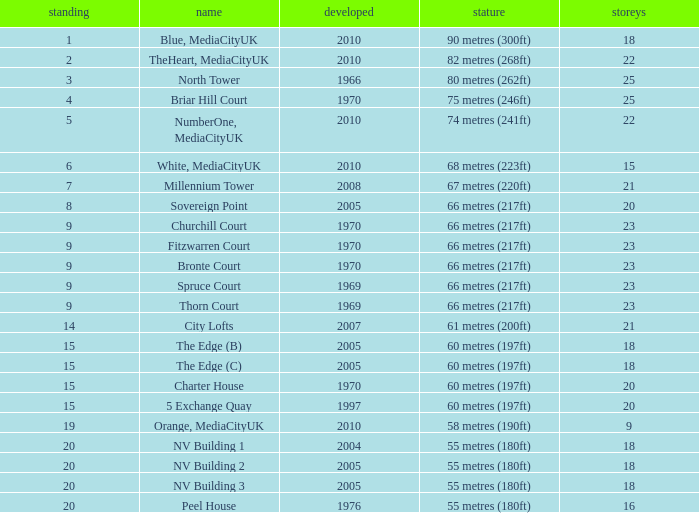What is the lowest Built, when Floors is greater than 23, and when Rank is 3? 1966.0. 